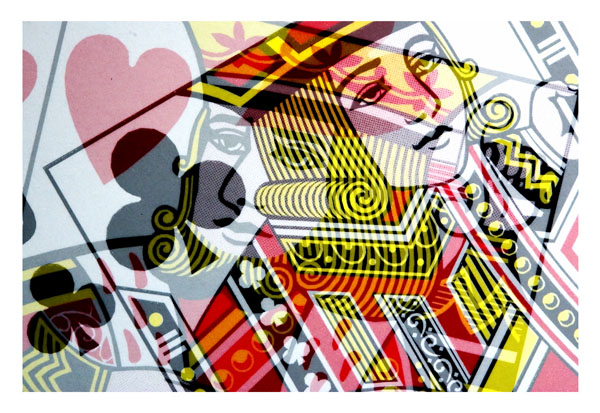How could these playing cards be utilized aside from traditional card games? Given their unique and artistic design, these playing cards could be used as decorative items, in artistic collages, or as part of educational activities to discuss art styles and graphic design. They could also serve as collectible items for enthusiasts of unique playing card designs. 